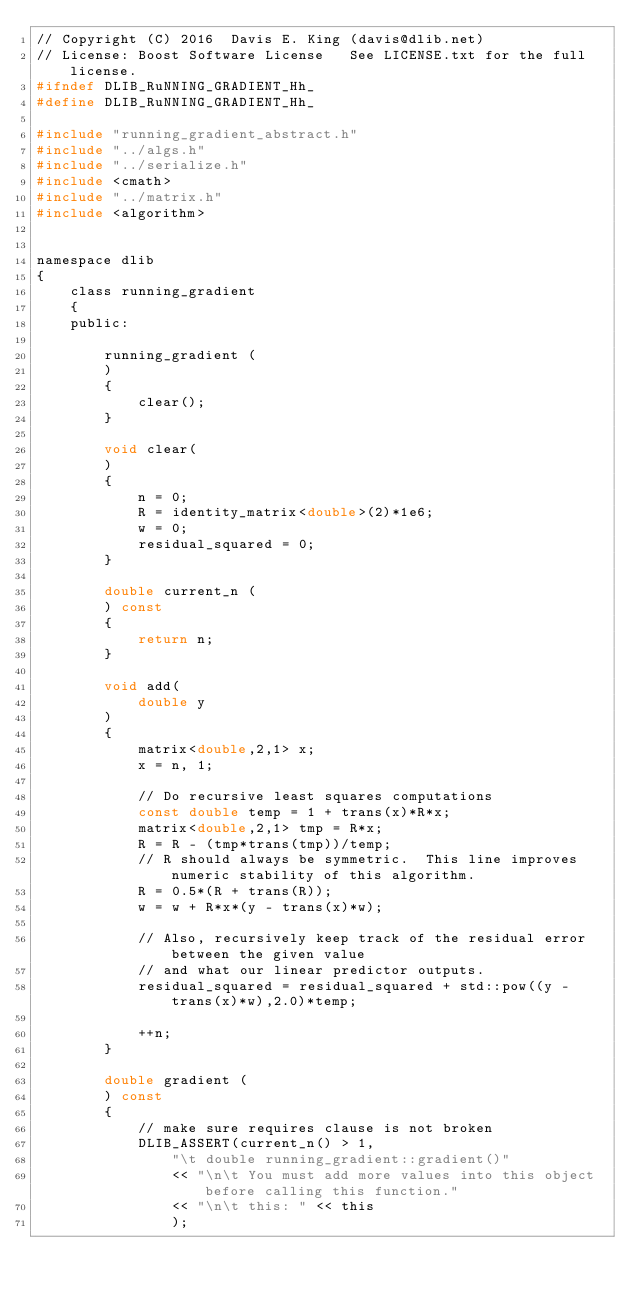Convert code to text. <code><loc_0><loc_0><loc_500><loc_500><_C_>// Copyright (C) 2016  Davis E. King (davis@dlib.net)
// License: Boost Software License   See LICENSE.txt for the full license.
#ifndef DLIB_RuNNING_GRADIENT_Hh_
#define DLIB_RuNNING_GRADIENT_Hh_

#include "running_gradient_abstract.h"
#include "../algs.h"
#include "../serialize.h"
#include <cmath>
#include "../matrix.h"
#include <algorithm>


namespace dlib
{
    class running_gradient
    {
    public:

        running_gradient (
        )
        {
            clear();
        }

        void clear(
        )
        {
            n = 0;
            R = identity_matrix<double>(2)*1e6;
            w = 0;
            residual_squared = 0;
        }

        double current_n (
        ) const
        {
            return n;
        }

        void add(
            double y
        )
        {
            matrix<double,2,1> x;
            x = n, 1;

            // Do recursive least squares computations
            const double temp = 1 + trans(x)*R*x;
            matrix<double,2,1> tmp = R*x;
            R = R - (tmp*trans(tmp))/temp;
            // R should always be symmetric.  This line improves numeric stability of this algorithm.
            R = 0.5*(R + trans(R));
            w = w + R*x*(y - trans(x)*w);

            // Also, recursively keep track of the residual error between the given value
            // and what our linear predictor outputs.
            residual_squared = residual_squared + std::pow((y - trans(x)*w),2.0)*temp;

            ++n;
        }

        double gradient (
        ) const
        {
            // make sure requires clause is not broken
            DLIB_ASSERT(current_n() > 1,
                "\t double running_gradient::gradient()"
                << "\n\t You must add more values into this object before calling this function."
                << "\n\t this: " << this
                );
</code> 